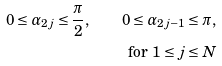Convert formula to latex. <formula><loc_0><loc_0><loc_500><loc_500>0 \leq \alpha _ { 2 j } \leq \frac { \pi } { 2 } , \quad 0 \leq \alpha _ { 2 j - 1 } \leq \pi , \\ \text { for } 1 \leq j \leq N</formula> 